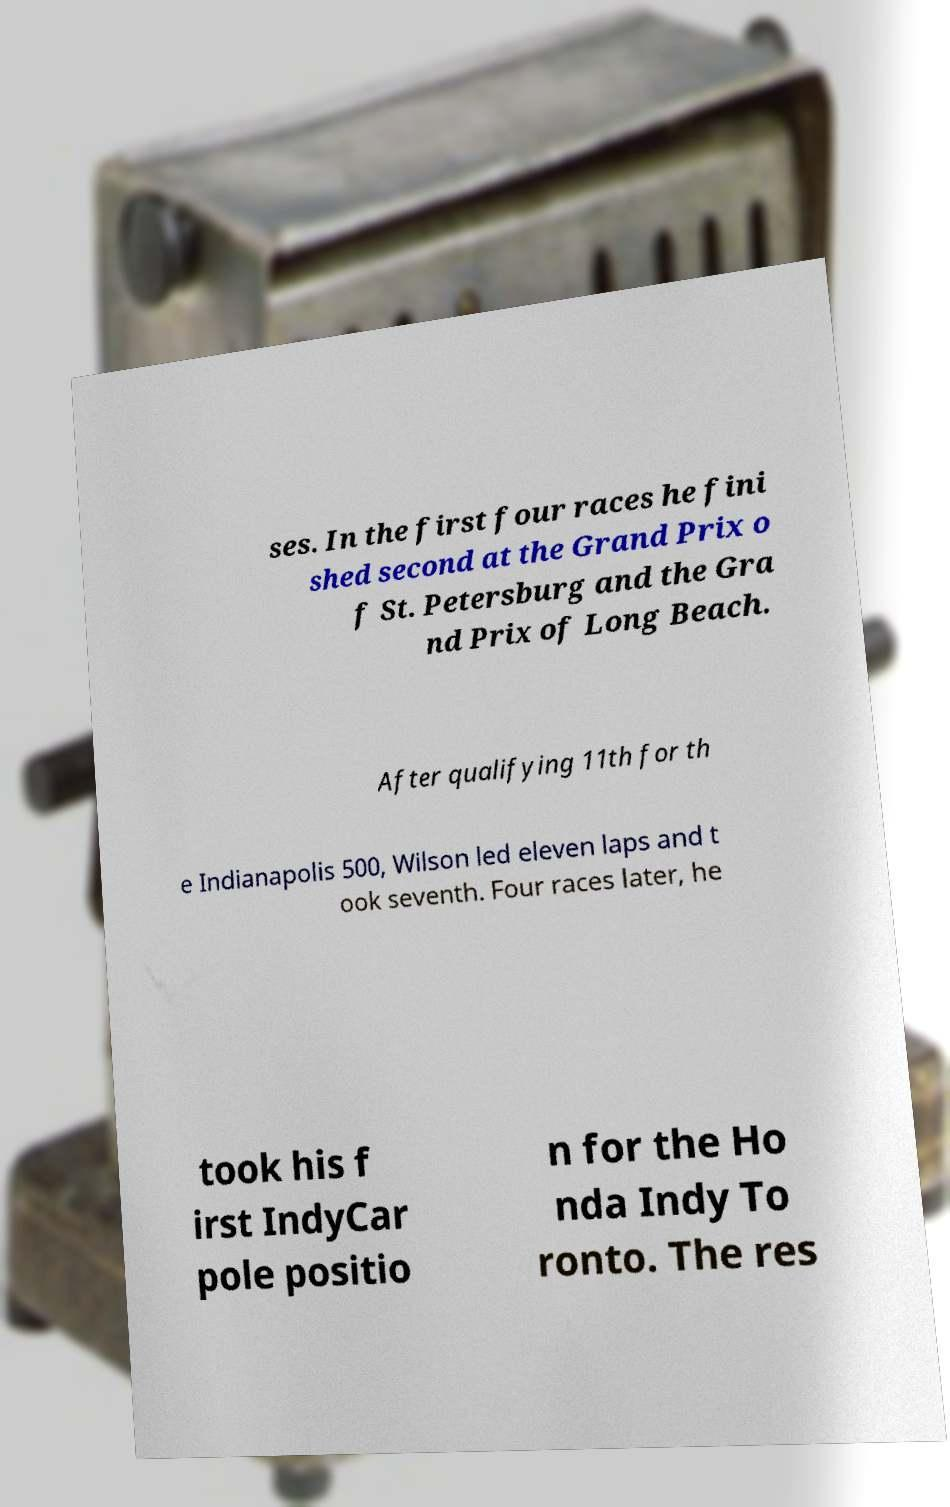Can you accurately transcribe the text from the provided image for me? ses. In the first four races he fini shed second at the Grand Prix o f St. Petersburg and the Gra nd Prix of Long Beach. After qualifying 11th for th e Indianapolis 500, Wilson led eleven laps and t ook seventh. Four races later, he took his f irst IndyCar pole positio n for the Ho nda Indy To ronto. The res 